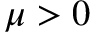<formula> <loc_0><loc_0><loc_500><loc_500>\mu > 0</formula> 